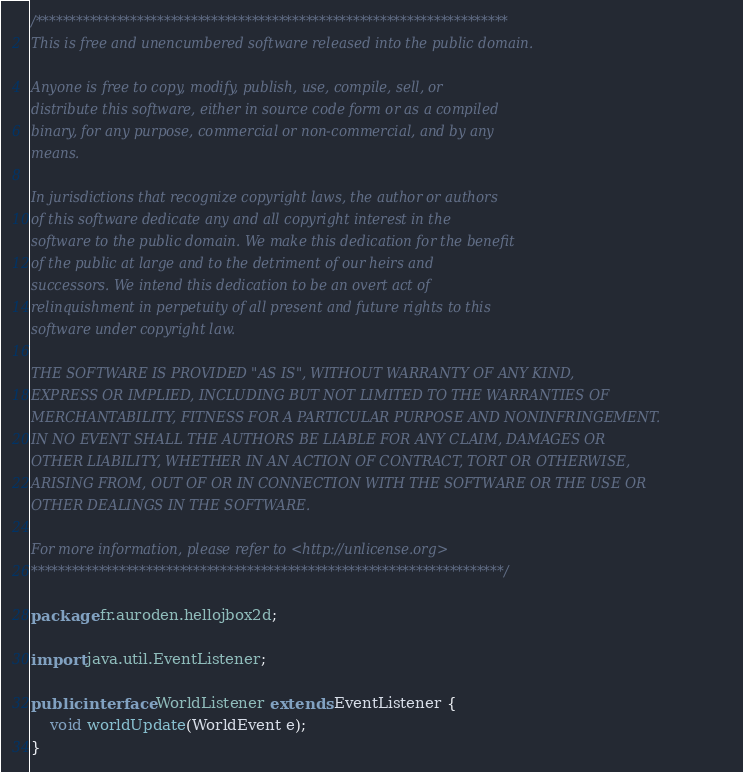<code> <loc_0><loc_0><loc_500><loc_500><_Java_>/**********************************************************************
This is free and unencumbered software released into the public domain.

Anyone is free to copy, modify, publish, use, compile, sell, or
distribute this software, either in source code form or as a compiled
binary, for any purpose, commercial or non-commercial, and by any
means.

In jurisdictions that recognize copyright laws, the author or authors
of this software dedicate any and all copyright interest in the
software to the public domain. We make this dedication for the benefit
of the public at large and to the detriment of our heirs and
successors. We intend this dedication to be an overt act of
relinquishment in perpetuity of all present and future rights to this
software under copyright law.

THE SOFTWARE IS PROVIDED "AS IS", WITHOUT WARRANTY OF ANY KIND,
EXPRESS OR IMPLIED, INCLUDING BUT NOT LIMITED TO THE WARRANTIES OF
MERCHANTABILITY, FITNESS FOR A PARTICULAR PURPOSE AND NONINFRINGEMENT.
IN NO EVENT SHALL THE AUTHORS BE LIABLE FOR ANY CLAIM, DAMAGES OR
OTHER LIABILITY, WHETHER IN AN ACTION OF CONTRACT, TORT OR OTHERWISE,
ARISING FROM, OUT OF OR IN CONNECTION WITH THE SOFTWARE OR THE USE OR
OTHER DEALINGS IN THE SOFTWARE.

For more information, please refer to <http://unlicense.org>
**********************************************************************/

package fr.auroden.hellojbox2d;

import java.util.EventListener;

public interface WorldListener extends EventListener {
	void worldUpdate(WorldEvent e);
}
</code> 